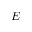<formula> <loc_0><loc_0><loc_500><loc_500>{ \boldsymbol E }</formula> 